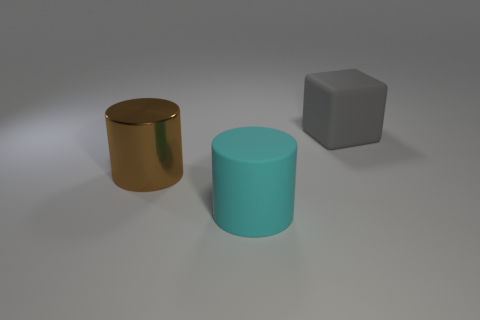Are there fewer small blue matte cylinders than large rubber cylinders?
Offer a very short reply. Yes. How big is the thing that is behind the large cyan cylinder and to the right of the metal cylinder?
Offer a very short reply. Large. There is a thing right of the rubber object left of the big matte thing that is to the right of the large cyan rubber cylinder; what size is it?
Offer a terse response. Large. Do the rubber object in front of the gray rubber thing and the shiny thing have the same color?
Give a very brief answer. No. How many things are tiny purple cubes or big brown metal objects?
Ensure brevity in your answer.  1. What is the color of the object that is on the right side of the big matte cylinder?
Provide a short and direct response. Gray. Are there fewer brown metal things to the left of the shiny cylinder than cyan matte balls?
Offer a terse response. No. Are there any other things that have the same size as the metal object?
Provide a succinct answer. Yes. Are the brown object and the cyan thing made of the same material?
Your answer should be very brief. No. What number of things are either brown metal objects on the left side of the large cyan rubber object or cylinders behind the cyan thing?
Provide a succinct answer. 1. 